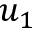<formula> <loc_0><loc_0><loc_500><loc_500>u _ { 1 }</formula> 